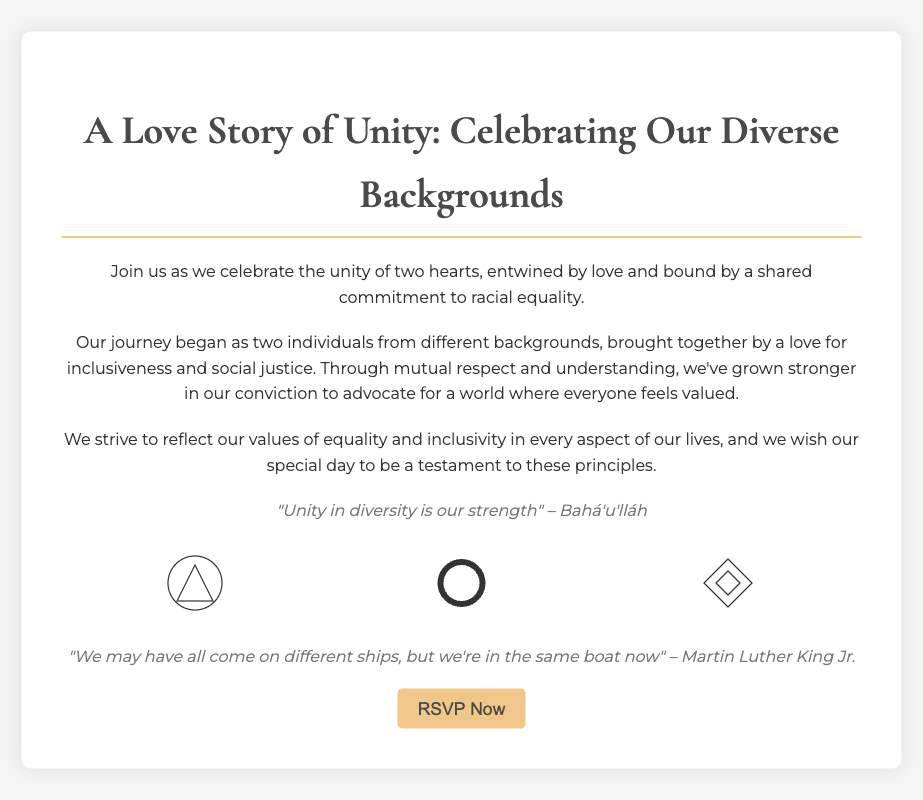What is the title of the invitation? The title of the invitation is prominently displayed at the top of the document in a larger font.
Answer: A Love Story of Unity: Celebrating Our Diverse Backgrounds What is the central theme of the couple's journey? The theme is emphasized in the introductory paragraph that details their bond and shared values.
Answer: Racial equality Who is quoted in the document? The quotes provided are attributed to notable figures, which can be identified in the quote sections.
Answer: Bahá'u'lláh and Martin Luther King Jr What symbols are displayed in the invitation? Three specific cultural symbols are depicted in the symbols section, representing different heritages.
Answer: Adinkra, Celtic, and Native What is the color of the call-to-action button? The button color can be easily identified based on its visual presentation in the document.
Answer: F0c789 What underlying value do the couple’s values reflect? This value is explicitly explained in the narrative of their journey and commitment to community.
Answer: Inclusiveness How does the couple aim to celebrate their special day? They express a desire to embody their values and principles through the details of their wedding.
Answer: A testament to these principles What is the intended response action at the end of the invitation? The last part of the document encourages readers to take immediate action concerning their attendance.
Answer: RSVP Now 